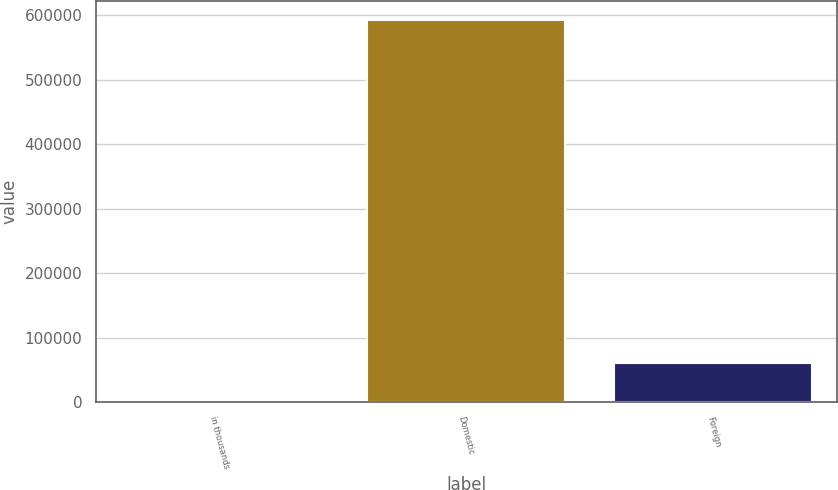Convert chart to OTSL. <chart><loc_0><loc_0><loc_500><loc_500><bar_chart><fcel>in thousands<fcel>Domestic<fcel>Foreign<nl><fcel>2018<fcel>593446<fcel>61160.8<nl></chart> 